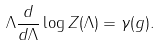<formula> <loc_0><loc_0><loc_500><loc_500>\Lambda \frac { d } { d \Lambda } \log Z ( \Lambda ) = \gamma ( g ) .</formula> 